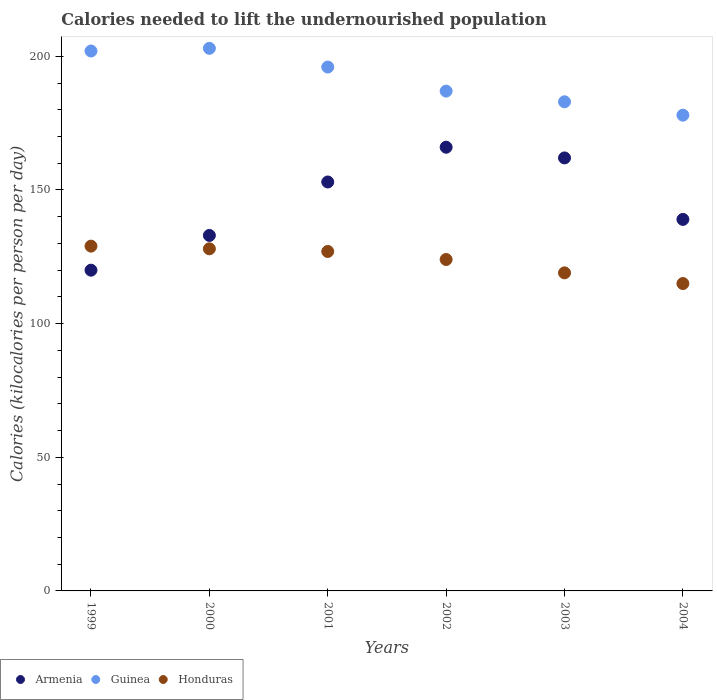How many different coloured dotlines are there?
Keep it short and to the point. 3. What is the total calories needed to lift the undernourished population in Armenia in 2002?
Make the answer very short. 166. Across all years, what is the maximum total calories needed to lift the undernourished population in Armenia?
Your answer should be very brief. 166. Across all years, what is the minimum total calories needed to lift the undernourished population in Honduras?
Ensure brevity in your answer.  115. In which year was the total calories needed to lift the undernourished population in Armenia minimum?
Make the answer very short. 1999. What is the total total calories needed to lift the undernourished population in Armenia in the graph?
Ensure brevity in your answer.  873. What is the difference between the total calories needed to lift the undernourished population in Honduras in 2001 and that in 2002?
Your response must be concise. 3. What is the difference between the total calories needed to lift the undernourished population in Armenia in 2003 and the total calories needed to lift the undernourished population in Honduras in 2001?
Your response must be concise. 35. What is the average total calories needed to lift the undernourished population in Armenia per year?
Your answer should be compact. 145.5. In the year 2003, what is the difference between the total calories needed to lift the undernourished population in Armenia and total calories needed to lift the undernourished population in Honduras?
Your answer should be very brief. 43. In how many years, is the total calories needed to lift the undernourished population in Honduras greater than 170 kilocalories?
Provide a short and direct response. 0. What is the ratio of the total calories needed to lift the undernourished population in Armenia in 1999 to that in 2002?
Make the answer very short. 0.72. What is the difference between the highest and the second highest total calories needed to lift the undernourished population in Armenia?
Offer a terse response. 4. What is the difference between the highest and the lowest total calories needed to lift the undernourished population in Guinea?
Make the answer very short. 25. Is the total calories needed to lift the undernourished population in Guinea strictly less than the total calories needed to lift the undernourished population in Honduras over the years?
Provide a short and direct response. No. Are the values on the major ticks of Y-axis written in scientific E-notation?
Your response must be concise. No. Where does the legend appear in the graph?
Your answer should be compact. Bottom left. How many legend labels are there?
Your answer should be compact. 3. How are the legend labels stacked?
Offer a terse response. Horizontal. What is the title of the graph?
Ensure brevity in your answer.  Calories needed to lift the undernourished population. What is the label or title of the X-axis?
Your response must be concise. Years. What is the label or title of the Y-axis?
Keep it short and to the point. Calories (kilocalories per person per day). What is the Calories (kilocalories per person per day) in Armenia in 1999?
Give a very brief answer. 120. What is the Calories (kilocalories per person per day) of Guinea in 1999?
Offer a terse response. 202. What is the Calories (kilocalories per person per day) of Honduras in 1999?
Your answer should be very brief. 129. What is the Calories (kilocalories per person per day) in Armenia in 2000?
Your response must be concise. 133. What is the Calories (kilocalories per person per day) of Guinea in 2000?
Your response must be concise. 203. What is the Calories (kilocalories per person per day) of Honduras in 2000?
Give a very brief answer. 128. What is the Calories (kilocalories per person per day) of Armenia in 2001?
Give a very brief answer. 153. What is the Calories (kilocalories per person per day) of Guinea in 2001?
Provide a succinct answer. 196. What is the Calories (kilocalories per person per day) in Honduras in 2001?
Offer a terse response. 127. What is the Calories (kilocalories per person per day) of Armenia in 2002?
Your answer should be compact. 166. What is the Calories (kilocalories per person per day) of Guinea in 2002?
Provide a short and direct response. 187. What is the Calories (kilocalories per person per day) of Honduras in 2002?
Provide a succinct answer. 124. What is the Calories (kilocalories per person per day) in Armenia in 2003?
Make the answer very short. 162. What is the Calories (kilocalories per person per day) of Guinea in 2003?
Give a very brief answer. 183. What is the Calories (kilocalories per person per day) in Honduras in 2003?
Provide a succinct answer. 119. What is the Calories (kilocalories per person per day) in Armenia in 2004?
Make the answer very short. 139. What is the Calories (kilocalories per person per day) in Guinea in 2004?
Ensure brevity in your answer.  178. What is the Calories (kilocalories per person per day) of Honduras in 2004?
Make the answer very short. 115. Across all years, what is the maximum Calories (kilocalories per person per day) in Armenia?
Ensure brevity in your answer.  166. Across all years, what is the maximum Calories (kilocalories per person per day) of Guinea?
Ensure brevity in your answer.  203. Across all years, what is the maximum Calories (kilocalories per person per day) of Honduras?
Offer a very short reply. 129. Across all years, what is the minimum Calories (kilocalories per person per day) of Armenia?
Offer a very short reply. 120. Across all years, what is the minimum Calories (kilocalories per person per day) of Guinea?
Your answer should be compact. 178. Across all years, what is the minimum Calories (kilocalories per person per day) in Honduras?
Your response must be concise. 115. What is the total Calories (kilocalories per person per day) in Armenia in the graph?
Offer a terse response. 873. What is the total Calories (kilocalories per person per day) of Guinea in the graph?
Your answer should be compact. 1149. What is the total Calories (kilocalories per person per day) of Honduras in the graph?
Provide a short and direct response. 742. What is the difference between the Calories (kilocalories per person per day) of Armenia in 1999 and that in 2000?
Keep it short and to the point. -13. What is the difference between the Calories (kilocalories per person per day) of Armenia in 1999 and that in 2001?
Offer a very short reply. -33. What is the difference between the Calories (kilocalories per person per day) in Guinea in 1999 and that in 2001?
Make the answer very short. 6. What is the difference between the Calories (kilocalories per person per day) of Armenia in 1999 and that in 2002?
Offer a terse response. -46. What is the difference between the Calories (kilocalories per person per day) in Honduras in 1999 and that in 2002?
Offer a terse response. 5. What is the difference between the Calories (kilocalories per person per day) in Armenia in 1999 and that in 2003?
Your response must be concise. -42. What is the difference between the Calories (kilocalories per person per day) in Honduras in 2000 and that in 2001?
Ensure brevity in your answer.  1. What is the difference between the Calories (kilocalories per person per day) of Armenia in 2000 and that in 2002?
Your response must be concise. -33. What is the difference between the Calories (kilocalories per person per day) of Armenia in 2000 and that in 2004?
Offer a terse response. -6. What is the difference between the Calories (kilocalories per person per day) in Guinea in 2000 and that in 2004?
Your answer should be compact. 25. What is the difference between the Calories (kilocalories per person per day) in Honduras in 2000 and that in 2004?
Provide a short and direct response. 13. What is the difference between the Calories (kilocalories per person per day) of Guinea in 2001 and that in 2002?
Offer a terse response. 9. What is the difference between the Calories (kilocalories per person per day) in Honduras in 2001 and that in 2002?
Make the answer very short. 3. What is the difference between the Calories (kilocalories per person per day) of Guinea in 2001 and that in 2003?
Give a very brief answer. 13. What is the difference between the Calories (kilocalories per person per day) in Honduras in 2001 and that in 2003?
Give a very brief answer. 8. What is the difference between the Calories (kilocalories per person per day) in Armenia in 2001 and that in 2004?
Offer a very short reply. 14. What is the difference between the Calories (kilocalories per person per day) in Honduras in 2001 and that in 2004?
Provide a succinct answer. 12. What is the difference between the Calories (kilocalories per person per day) in Armenia in 2002 and that in 2003?
Make the answer very short. 4. What is the difference between the Calories (kilocalories per person per day) in Guinea in 2002 and that in 2003?
Give a very brief answer. 4. What is the difference between the Calories (kilocalories per person per day) of Honduras in 2002 and that in 2003?
Ensure brevity in your answer.  5. What is the difference between the Calories (kilocalories per person per day) in Honduras in 2002 and that in 2004?
Your answer should be very brief. 9. What is the difference between the Calories (kilocalories per person per day) in Armenia in 2003 and that in 2004?
Provide a succinct answer. 23. What is the difference between the Calories (kilocalories per person per day) of Honduras in 2003 and that in 2004?
Keep it short and to the point. 4. What is the difference between the Calories (kilocalories per person per day) of Armenia in 1999 and the Calories (kilocalories per person per day) of Guinea in 2000?
Your response must be concise. -83. What is the difference between the Calories (kilocalories per person per day) of Armenia in 1999 and the Calories (kilocalories per person per day) of Honduras in 2000?
Provide a succinct answer. -8. What is the difference between the Calories (kilocalories per person per day) of Guinea in 1999 and the Calories (kilocalories per person per day) of Honduras in 2000?
Your answer should be compact. 74. What is the difference between the Calories (kilocalories per person per day) in Armenia in 1999 and the Calories (kilocalories per person per day) in Guinea in 2001?
Your answer should be very brief. -76. What is the difference between the Calories (kilocalories per person per day) in Armenia in 1999 and the Calories (kilocalories per person per day) in Honduras in 2001?
Provide a short and direct response. -7. What is the difference between the Calories (kilocalories per person per day) in Armenia in 1999 and the Calories (kilocalories per person per day) in Guinea in 2002?
Offer a very short reply. -67. What is the difference between the Calories (kilocalories per person per day) of Guinea in 1999 and the Calories (kilocalories per person per day) of Honduras in 2002?
Your response must be concise. 78. What is the difference between the Calories (kilocalories per person per day) of Armenia in 1999 and the Calories (kilocalories per person per day) of Guinea in 2003?
Your answer should be very brief. -63. What is the difference between the Calories (kilocalories per person per day) of Armenia in 1999 and the Calories (kilocalories per person per day) of Guinea in 2004?
Ensure brevity in your answer.  -58. What is the difference between the Calories (kilocalories per person per day) of Guinea in 1999 and the Calories (kilocalories per person per day) of Honduras in 2004?
Make the answer very short. 87. What is the difference between the Calories (kilocalories per person per day) of Armenia in 2000 and the Calories (kilocalories per person per day) of Guinea in 2001?
Offer a very short reply. -63. What is the difference between the Calories (kilocalories per person per day) of Guinea in 2000 and the Calories (kilocalories per person per day) of Honduras in 2001?
Provide a succinct answer. 76. What is the difference between the Calories (kilocalories per person per day) of Armenia in 2000 and the Calories (kilocalories per person per day) of Guinea in 2002?
Your answer should be compact. -54. What is the difference between the Calories (kilocalories per person per day) of Armenia in 2000 and the Calories (kilocalories per person per day) of Honduras in 2002?
Give a very brief answer. 9. What is the difference between the Calories (kilocalories per person per day) of Guinea in 2000 and the Calories (kilocalories per person per day) of Honduras in 2002?
Offer a very short reply. 79. What is the difference between the Calories (kilocalories per person per day) of Guinea in 2000 and the Calories (kilocalories per person per day) of Honduras in 2003?
Your answer should be compact. 84. What is the difference between the Calories (kilocalories per person per day) in Armenia in 2000 and the Calories (kilocalories per person per day) in Guinea in 2004?
Your answer should be very brief. -45. What is the difference between the Calories (kilocalories per person per day) of Guinea in 2000 and the Calories (kilocalories per person per day) of Honduras in 2004?
Provide a succinct answer. 88. What is the difference between the Calories (kilocalories per person per day) in Armenia in 2001 and the Calories (kilocalories per person per day) in Guinea in 2002?
Your response must be concise. -34. What is the difference between the Calories (kilocalories per person per day) in Armenia in 2001 and the Calories (kilocalories per person per day) in Guinea in 2003?
Make the answer very short. -30. What is the difference between the Calories (kilocalories per person per day) of Armenia in 2001 and the Calories (kilocalories per person per day) of Guinea in 2004?
Make the answer very short. -25. What is the difference between the Calories (kilocalories per person per day) of Armenia in 2001 and the Calories (kilocalories per person per day) of Honduras in 2004?
Your answer should be compact. 38. What is the difference between the Calories (kilocalories per person per day) of Armenia in 2002 and the Calories (kilocalories per person per day) of Guinea in 2003?
Your answer should be compact. -17. What is the difference between the Calories (kilocalories per person per day) of Guinea in 2002 and the Calories (kilocalories per person per day) of Honduras in 2003?
Keep it short and to the point. 68. What is the difference between the Calories (kilocalories per person per day) of Armenia in 2002 and the Calories (kilocalories per person per day) of Honduras in 2004?
Ensure brevity in your answer.  51. What is the difference between the Calories (kilocalories per person per day) of Guinea in 2003 and the Calories (kilocalories per person per day) of Honduras in 2004?
Provide a short and direct response. 68. What is the average Calories (kilocalories per person per day) in Armenia per year?
Provide a short and direct response. 145.5. What is the average Calories (kilocalories per person per day) in Guinea per year?
Give a very brief answer. 191.5. What is the average Calories (kilocalories per person per day) in Honduras per year?
Make the answer very short. 123.67. In the year 1999, what is the difference between the Calories (kilocalories per person per day) in Armenia and Calories (kilocalories per person per day) in Guinea?
Give a very brief answer. -82. In the year 1999, what is the difference between the Calories (kilocalories per person per day) in Armenia and Calories (kilocalories per person per day) in Honduras?
Your answer should be very brief. -9. In the year 1999, what is the difference between the Calories (kilocalories per person per day) of Guinea and Calories (kilocalories per person per day) of Honduras?
Your answer should be compact. 73. In the year 2000, what is the difference between the Calories (kilocalories per person per day) of Armenia and Calories (kilocalories per person per day) of Guinea?
Give a very brief answer. -70. In the year 2000, what is the difference between the Calories (kilocalories per person per day) of Armenia and Calories (kilocalories per person per day) of Honduras?
Your answer should be very brief. 5. In the year 2001, what is the difference between the Calories (kilocalories per person per day) in Armenia and Calories (kilocalories per person per day) in Guinea?
Provide a short and direct response. -43. In the year 2001, what is the difference between the Calories (kilocalories per person per day) of Armenia and Calories (kilocalories per person per day) of Honduras?
Your answer should be very brief. 26. In the year 2002, what is the difference between the Calories (kilocalories per person per day) in Guinea and Calories (kilocalories per person per day) in Honduras?
Offer a terse response. 63. In the year 2004, what is the difference between the Calories (kilocalories per person per day) in Armenia and Calories (kilocalories per person per day) in Guinea?
Give a very brief answer. -39. What is the ratio of the Calories (kilocalories per person per day) in Armenia in 1999 to that in 2000?
Your answer should be compact. 0.9. What is the ratio of the Calories (kilocalories per person per day) of Guinea in 1999 to that in 2000?
Keep it short and to the point. 1. What is the ratio of the Calories (kilocalories per person per day) in Armenia in 1999 to that in 2001?
Provide a succinct answer. 0.78. What is the ratio of the Calories (kilocalories per person per day) in Guinea in 1999 to that in 2001?
Offer a very short reply. 1.03. What is the ratio of the Calories (kilocalories per person per day) of Honduras in 1999 to that in 2001?
Make the answer very short. 1.02. What is the ratio of the Calories (kilocalories per person per day) in Armenia in 1999 to that in 2002?
Your response must be concise. 0.72. What is the ratio of the Calories (kilocalories per person per day) in Guinea in 1999 to that in 2002?
Offer a terse response. 1.08. What is the ratio of the Calories (kilocalories per person per day) in Honduras in 1999 to that in 2002?
Your answer should be very brief. 1.04. What is the ratio of the Calories (kilocalories per person per day) in Armenia in 1999 to that in 2003?
Your response must be concise. 0.74. What is the ratio of the Calories (kilocalories per person per day) of Guinea in 1999 to that in 2003?
Offer a terse response. 1.1. What is the ratio of the Calories (kilocalories per person per day) of Honduras in 1999 to that in 2003?
Provide a succinct answer. 1.08. What is the ratio of the Calories (kilocalories per person per day) in Armenia in 1999 to that in 2004?
Offer a very short reply. 0.86. What is the ratio of the Calories (kilocalories per person per day) of Guinea in 1999 to that in 2004?
Offer a very short reply. 1.13. What is the ratio of the Calories (kilocalories per person per day) of Honduras in 1999 to that in 2004?
Your answer should be compact. 1.12. What is the ratio of the Calories (kilocalories per person per day) of Armenia in 2000 to that in 2001?
Provide a succinct answer. 0.87. What is the ratio of the Calories (kilocalories per person per day) in Guinea in 2000 to that in 2001?
Your answer should be compact. 1.04. What is the ratio of the Calories (kilocalories per person per day) in Honduras in 2000 to that in 2001?
Give a very brief answer. 1.01. What is the ratio of the Calories (kilocalories per person per day) in Armenia in 2000 to that in 2002?
Your answer should be compact. 0.8. What is the ratio of the Calories (kilocalories per person per day) in Guinea in 2000 to that in 2002?
Provide a short and direct response. 1.09. What is the ratio of the Calories (kilocalories per person per day) in Honduras in 2000 to that in 2002?
Your response must be concise. 1.03. What is the ratio of the Calories (kilocalories per person per day) in Armenia in 2000 to that in 2003?
Offer a very short reply. 0.82. What is the ratio of the Calories (kilocalories per person per day) in Guinea in 2000 to that in 2003?
Offer a very short reply. 1.11. What is the ratio of the Calories (kilocalories per person per day) in Honduras in 2000 to that in 2003?
Make the answer very short. 1.08. What is the ratio of the Calories (kilocalories per person per day) of Armenia in 2000 to that in 2004?
Your response must be concise. 0.96. What is the ratio of the Calories (kilocalories per person per day) of Guinea in 2000 to that in 2004?
Make the answer very short. 1.14. What is the ratio of the Calories (kilocalories per person per day) in Honduras in 2000 to that in 2004?
Give a very brief answer. 1.11. What is the ratio of the Calories (kilocalories per person per day) of Armenia in 2001 to that in 2002?
Offer a very short reply. 0.92. What is the ratio of the Calories (kilocalories per person per day) in Guinea in 2001 to that in 2002?
Make the answer very short. 1.05. What is the ratio of the Calories (kilocalories per person per day) of Honduras in 2001 to that in 2002?
Ensure brevity in your answer.  1.02. What is the ratio of the Calories (kilocalories per person per day) in Guinea in 2001 to that in 2003?
Offer a very short reply. 1.07. What is the ratio of the Calories (kilocalories per person per day) of Honduras in 2001 to that in 2003?
Provide a short and direct response. 1.07. What is the ratio of the Calories (kilocalories per person per day) of Armenia in 2001 to that in 2004?
Your answer should be very brief. 1.1. What is the ratio of the Calories (kilocalories per person per day) in Guinea in 2001 to that in 2004?
Your response must be concise. 1.1. What is the ratio of the Calories (kilocalories per person per day) in Honduras in 2001 to that in 2004?
Keep it short and to the point. 1.1. What is the ratio of the Calories (kilocalories per person per day) of Armenia in 2002 to that in 2003?
Your answer should be very brief. 1.02. What is the ratio of the Calories (kilocalories per person per day) in Guinea in 2002 to that in 2003?
Your answer should be compact. 1.02. What is the ratio of the Calories (kilocalories per person per day) in Honduras in 2002 to that in 2003?
Your response must be concise. 1.04. What is the ratio of the Calories (kilocalories per person per day) in Armenia in 2002 to that in 2004?
Provide a short and direct response. 1.19. What is the ratio of the Calories (kilocalories per person per day) of Guinea in 2002 to that in 2004?
Offer a very short reply. 1.05. What is the ratio of the Calories (kilocalories per person per day) in Honduras in 2002 to that in 2004?
Ensure brevity in your answer.  1.08. What is the ratio of the Calories (kilocalories per person per day) of Armenia in 2003 to that in 2004?
Provide a short and direct response. 1.17. What is the ratio of the Calories (kilocalories per person per day) in Guinea in 2003 to that in 2004?
Offer a terse response. 1.03. What is the ratio of the Calories (kilocalories per person per day) of Honduras in 2003 to that in 2004?
Your response must be concise. 1.03. What is the difference between the highest and the second highest Calories (kilocalories per person per day) in Honduras?
Give a very brief answer. 1. What is the difference between the highest and the lowest Calories (kilocalories per person per day) in Armenia?
Your answer should be very brief. 46. What is the difference between the highest and the lowest Calories (kilocalories per person per day) of Guinea?
Provide a short and direct response. 25. What is the difference between the highest and the lowest Calories (kilocalories per person per day) in Honduras?
Your response must be concise. 14. 